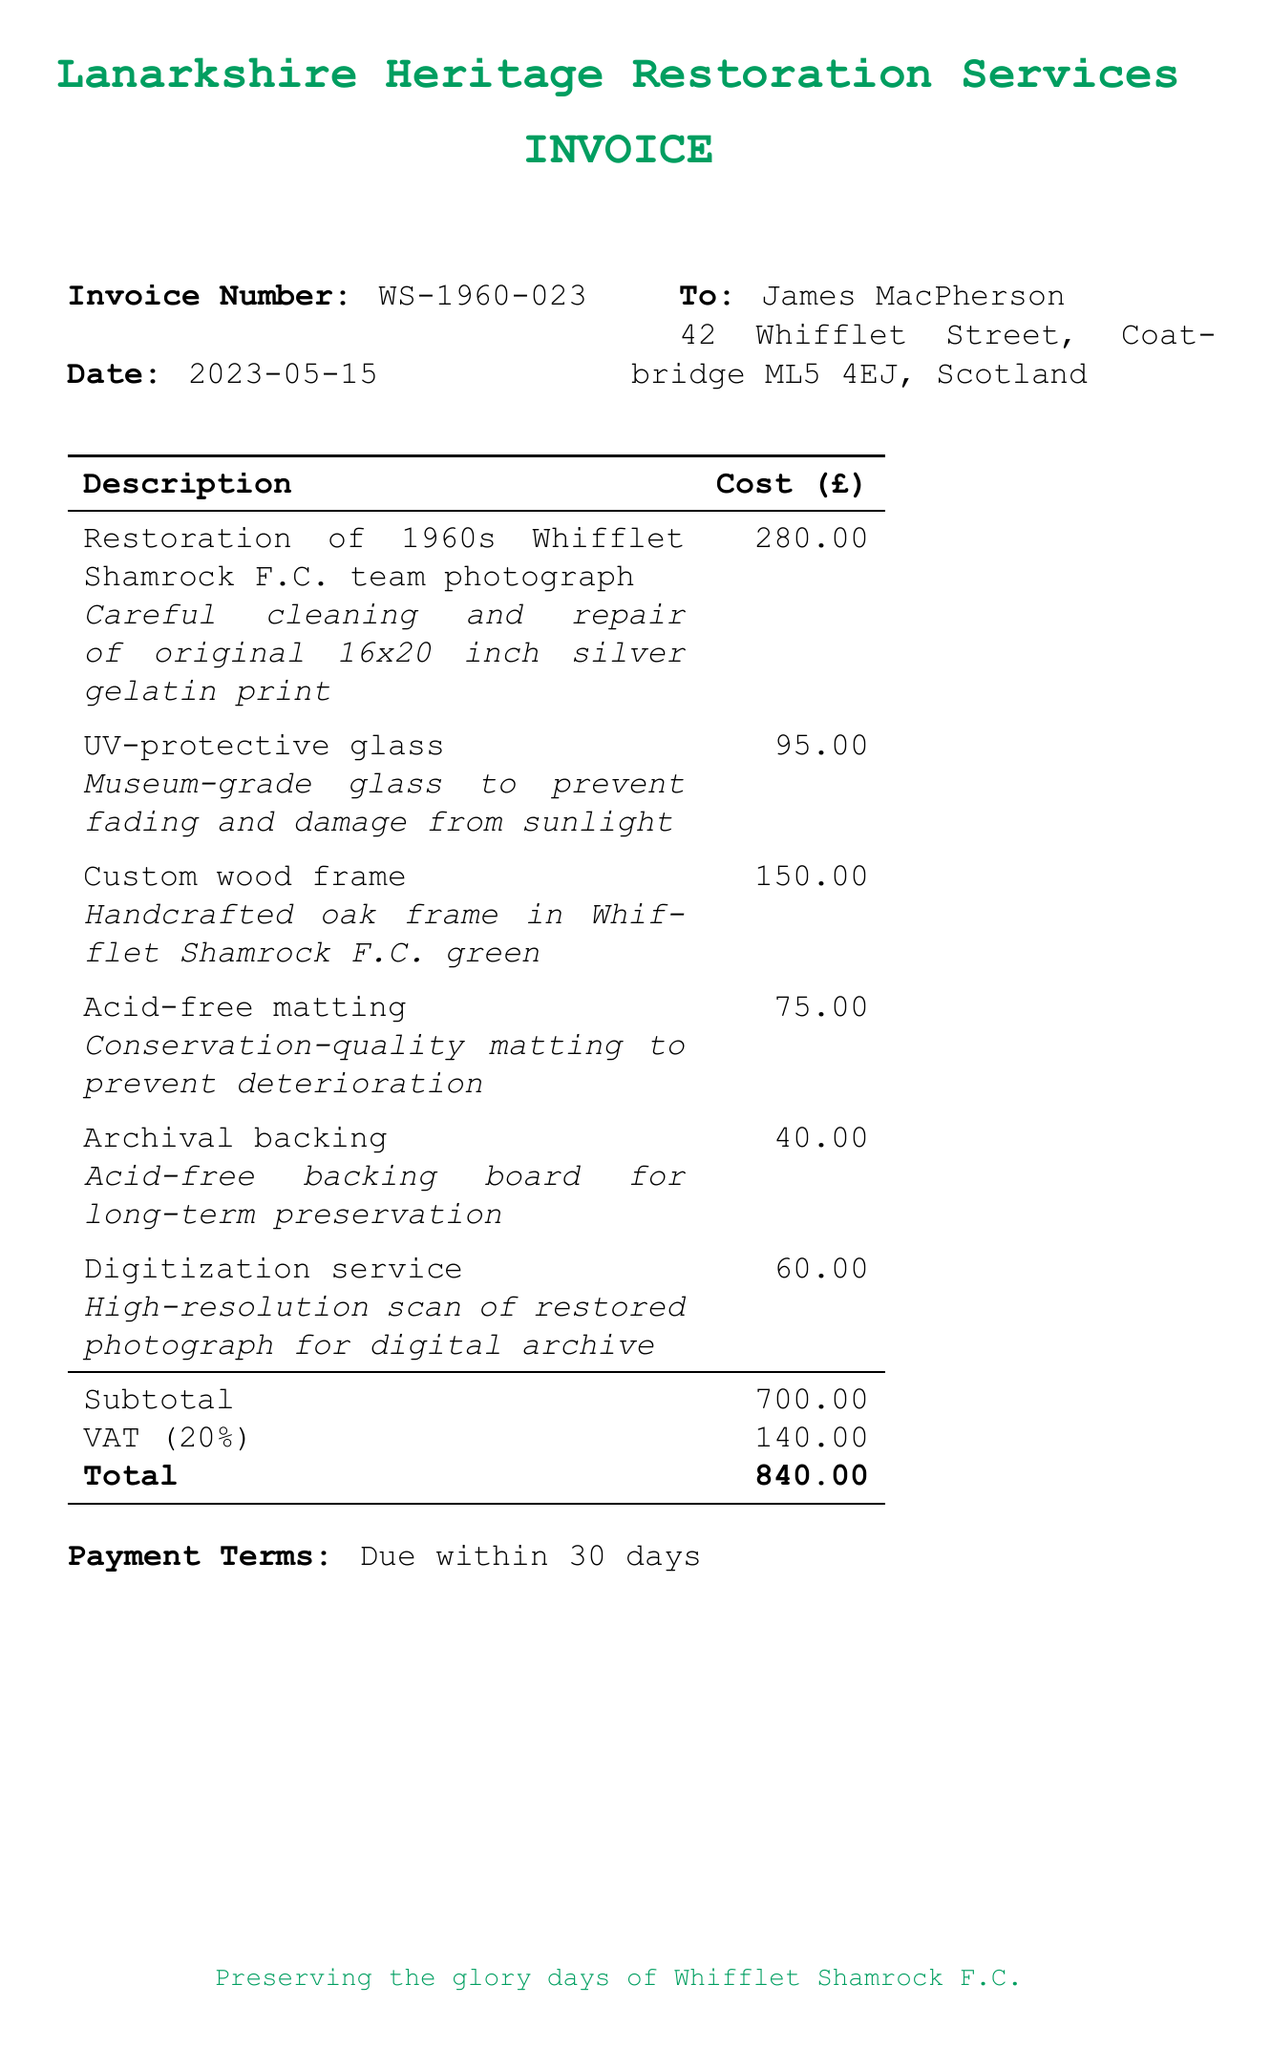What is the invoice number? The invoice number is listed at the top of the document for identification purposes.
Answer: WS-1960-023 Who is the customer? The name of the customer is specified in the billing section of the document.
Answer: James MacPherson What is the total amount due? The total amount due is calculated at the bottom of the invoice after listing all costs.
Answer: 840.00 What item has the highest cost? The item descriptions are listed with their corresponding costs, and the one with the highest value can be determined from that list.
Answer: Restoration of 1960s Whifflet Shamrock F.C. team photograph What is the date of the invoice? The date is provided near the invoice number for the record of when the invoice was issued.
Answer: 2023-05-15 Where is the service provider located? The service provider's name and their service offerings are mentioned at the top of the document, indicating their role in the invoice.
Answer: Lanarkshire Heritage Restoration Services What type of glass is used? The description details the specific features of the glass included in the restoration service.
Answer: UV-protective glass How much is the VAT? The VAT amount is clearly stated as a separate line item in the cost breakdown.
Answer: 140.00 What is the payment term? The payment term specifies the duration within which payment is required, as indicated in the invoice.
Answer: Due within 30 days 